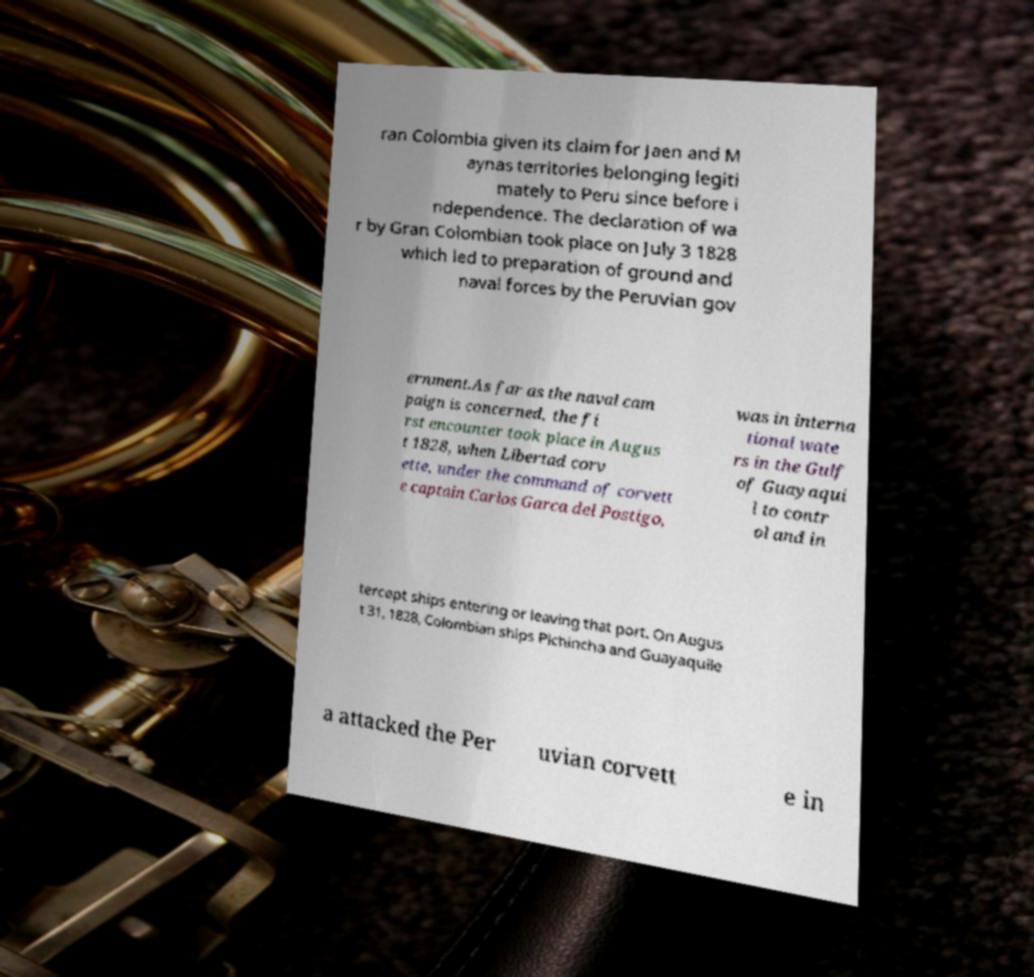Could you assist in decoding the text presented in this image and type it out clearly? ran Colombia given its claim for Jaen and M aynas territories belonging legiti mately to Peru since before i ndependence. The declaration of wa r by Gran Colombian took place on July 3 1828 which led to preparation of ground and naval forces by the Peruvian gov ernment.As far as the naval cam paign is concerned, the fi rst encounter took place in Augus t 1828, when Libertad corv ette, under the command of corvett e captain Carlos Garca del Postigo, was in interna tional wate rs in the Gulf of Guayaqui l to contr ol and in tercept ships entering or leaving that port. On Augus t 31, 1828, Colombian ships Pichincha and Guayaquile a attacked the Per uvian corvett e in 